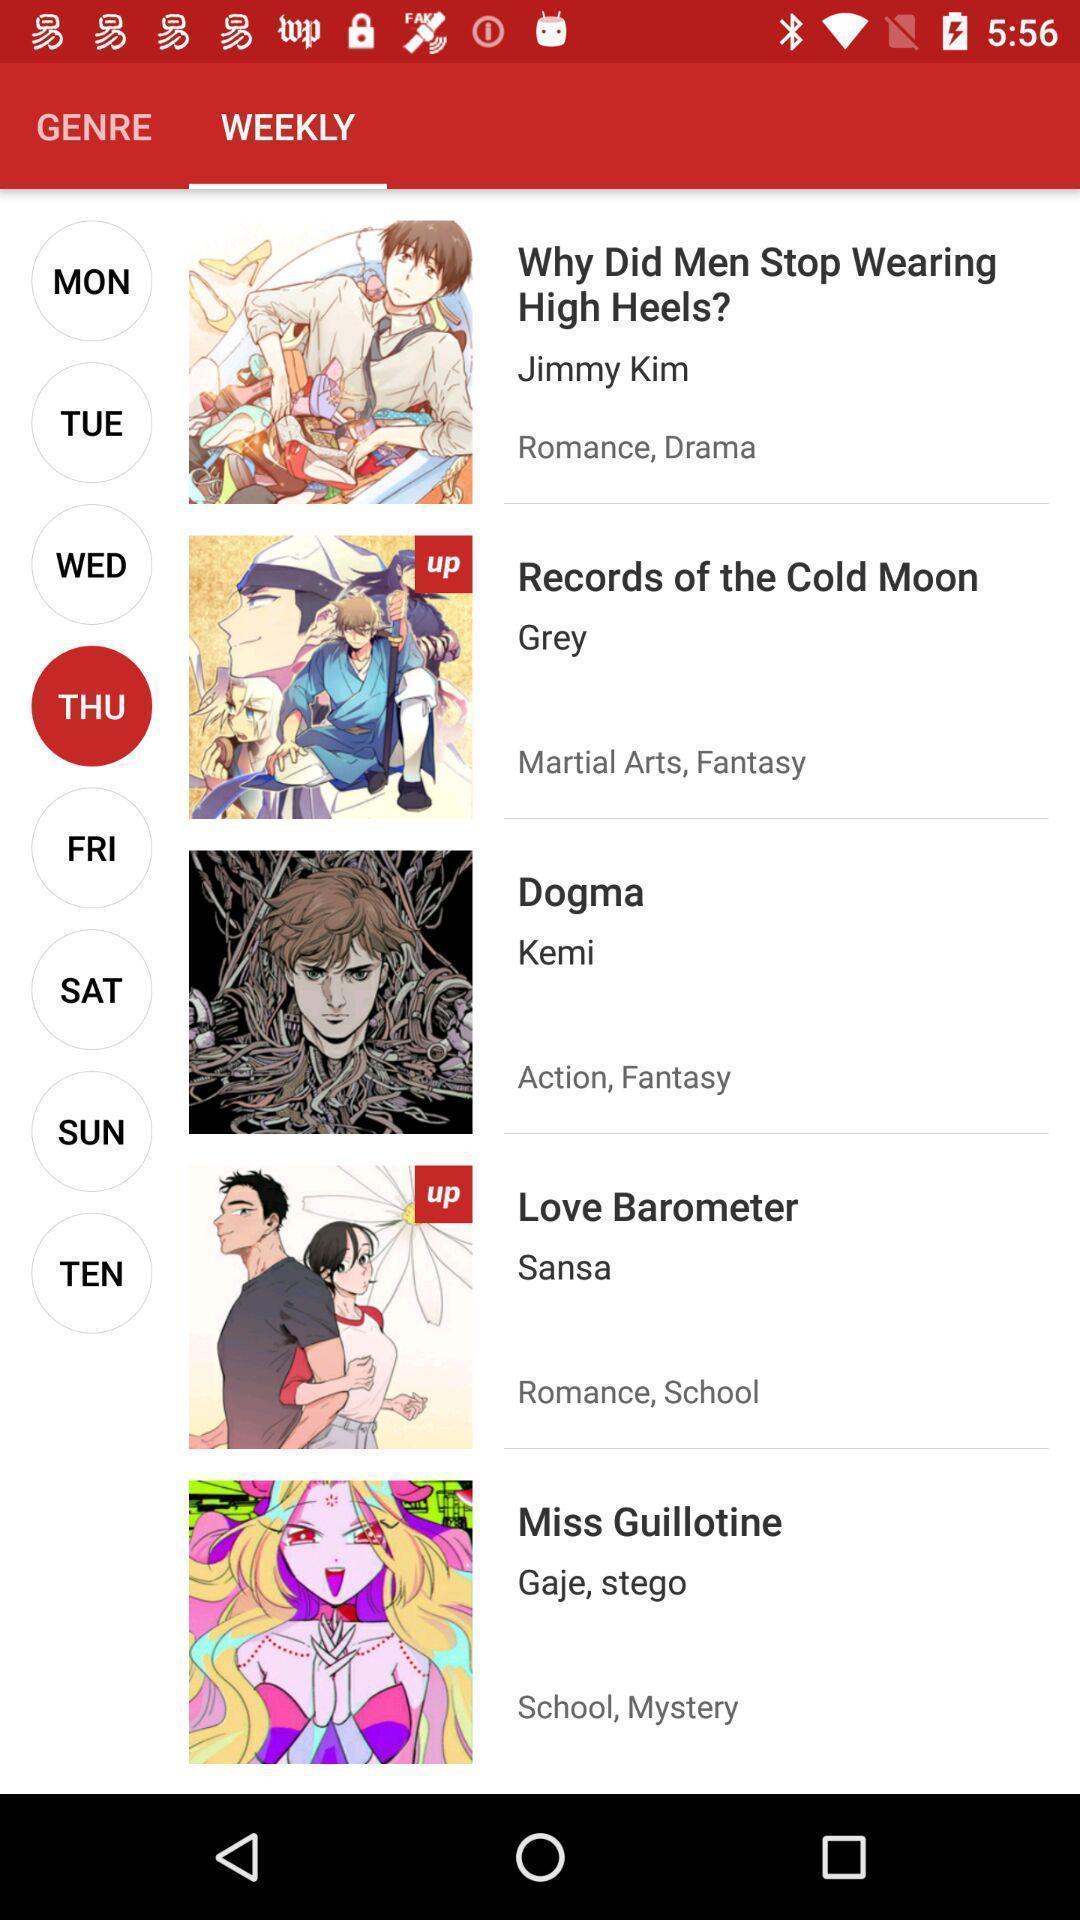What is the overall content of this screenshot? Page displays list of weekly comics in app. 